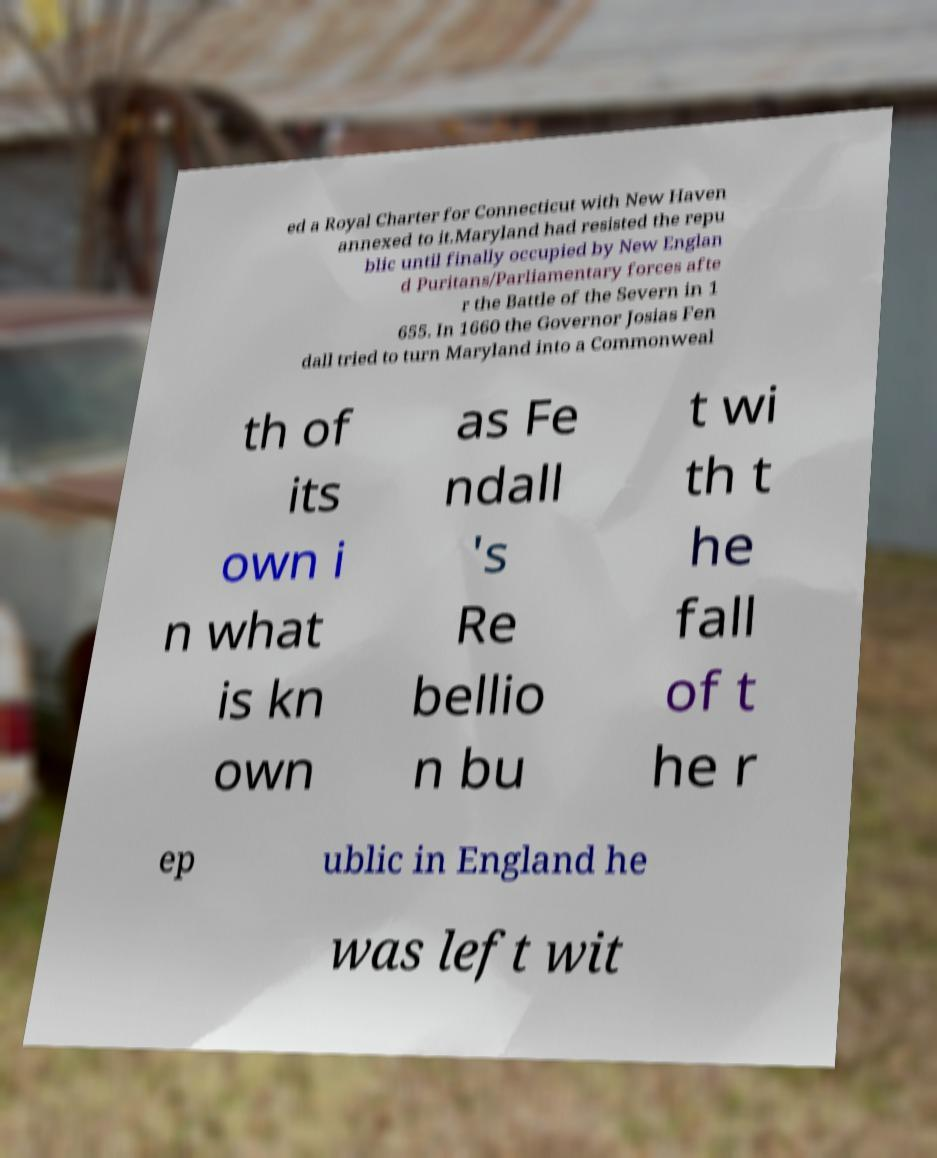Please identify and transcribe the text found in this image. ed a Royal Charter for Connecticut with New Haven annexed to it.Maryland had resisted the repu blic until finally occupied by New Englan d Puritans/Parliamentary forces afte r the Battle of the Severn in 1 655. In 1660 the Governor Josias Fen dall tried to turn Maryland into a Commonweal th of its own i n what is kn own as Fe ndall 's Re bellio n bu t wi th t he fall of t he r ep ublic in England he was left wit 